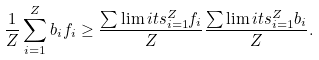<formula> <loc_0><loc_0><loc_500><loc_500>\frac { 1 } { Z } \sum ^ { Z } _ { i = 1 } b _ { i } f _ { i } \geq \frac { \sum \lim i t s ^ { Z } _ { i = 1 } f _ { i } } { Z } \frac { \sum \lim i t s ^ { Z } _ { i = 1 } b _ { i } } { Z } .</formula> 